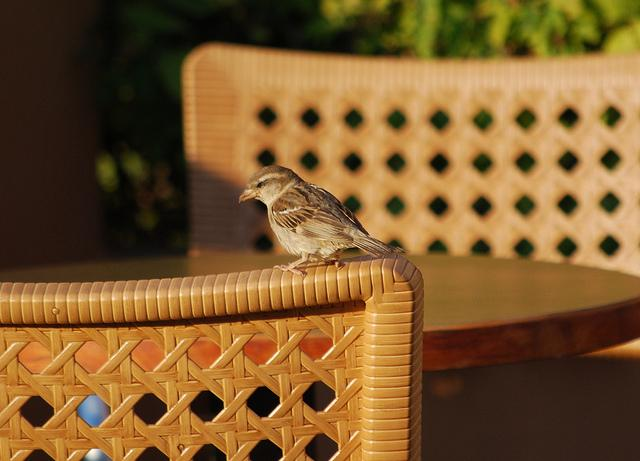What materials are the chairs made of? wicker 